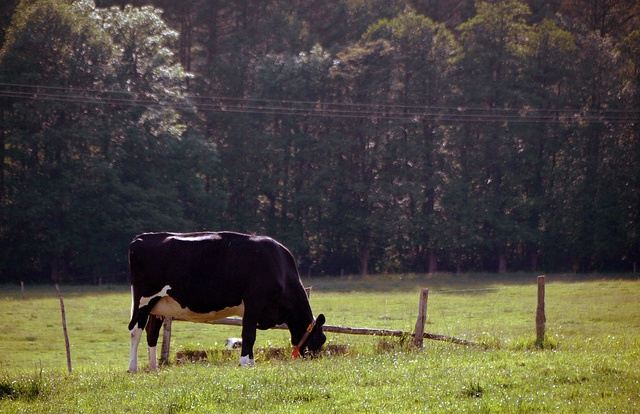Describe the objects in this image and their specific colors. I can see a cow in black, tan, maroon, and gray tones in this image. 